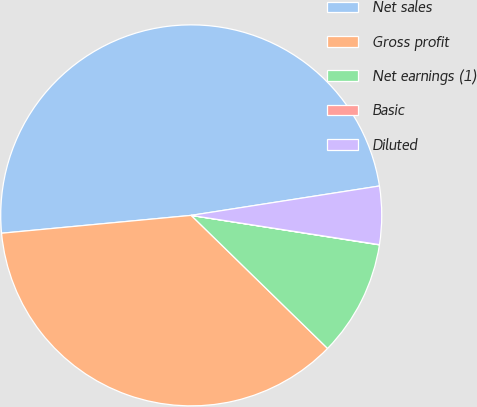Convert chart. <chart><loc_0><loc_0><loc_500><loc_500><pie_chart><fcel>Net sales<fcel>Gross profit<fcel>Net earnings (1)<fcel>Basic<fcel>Diluted<nl><fcel>49.03%<fcel>36.2%<fcel>9.83%<fcel>0.02%<fcel>4.92%<nl></chart> 